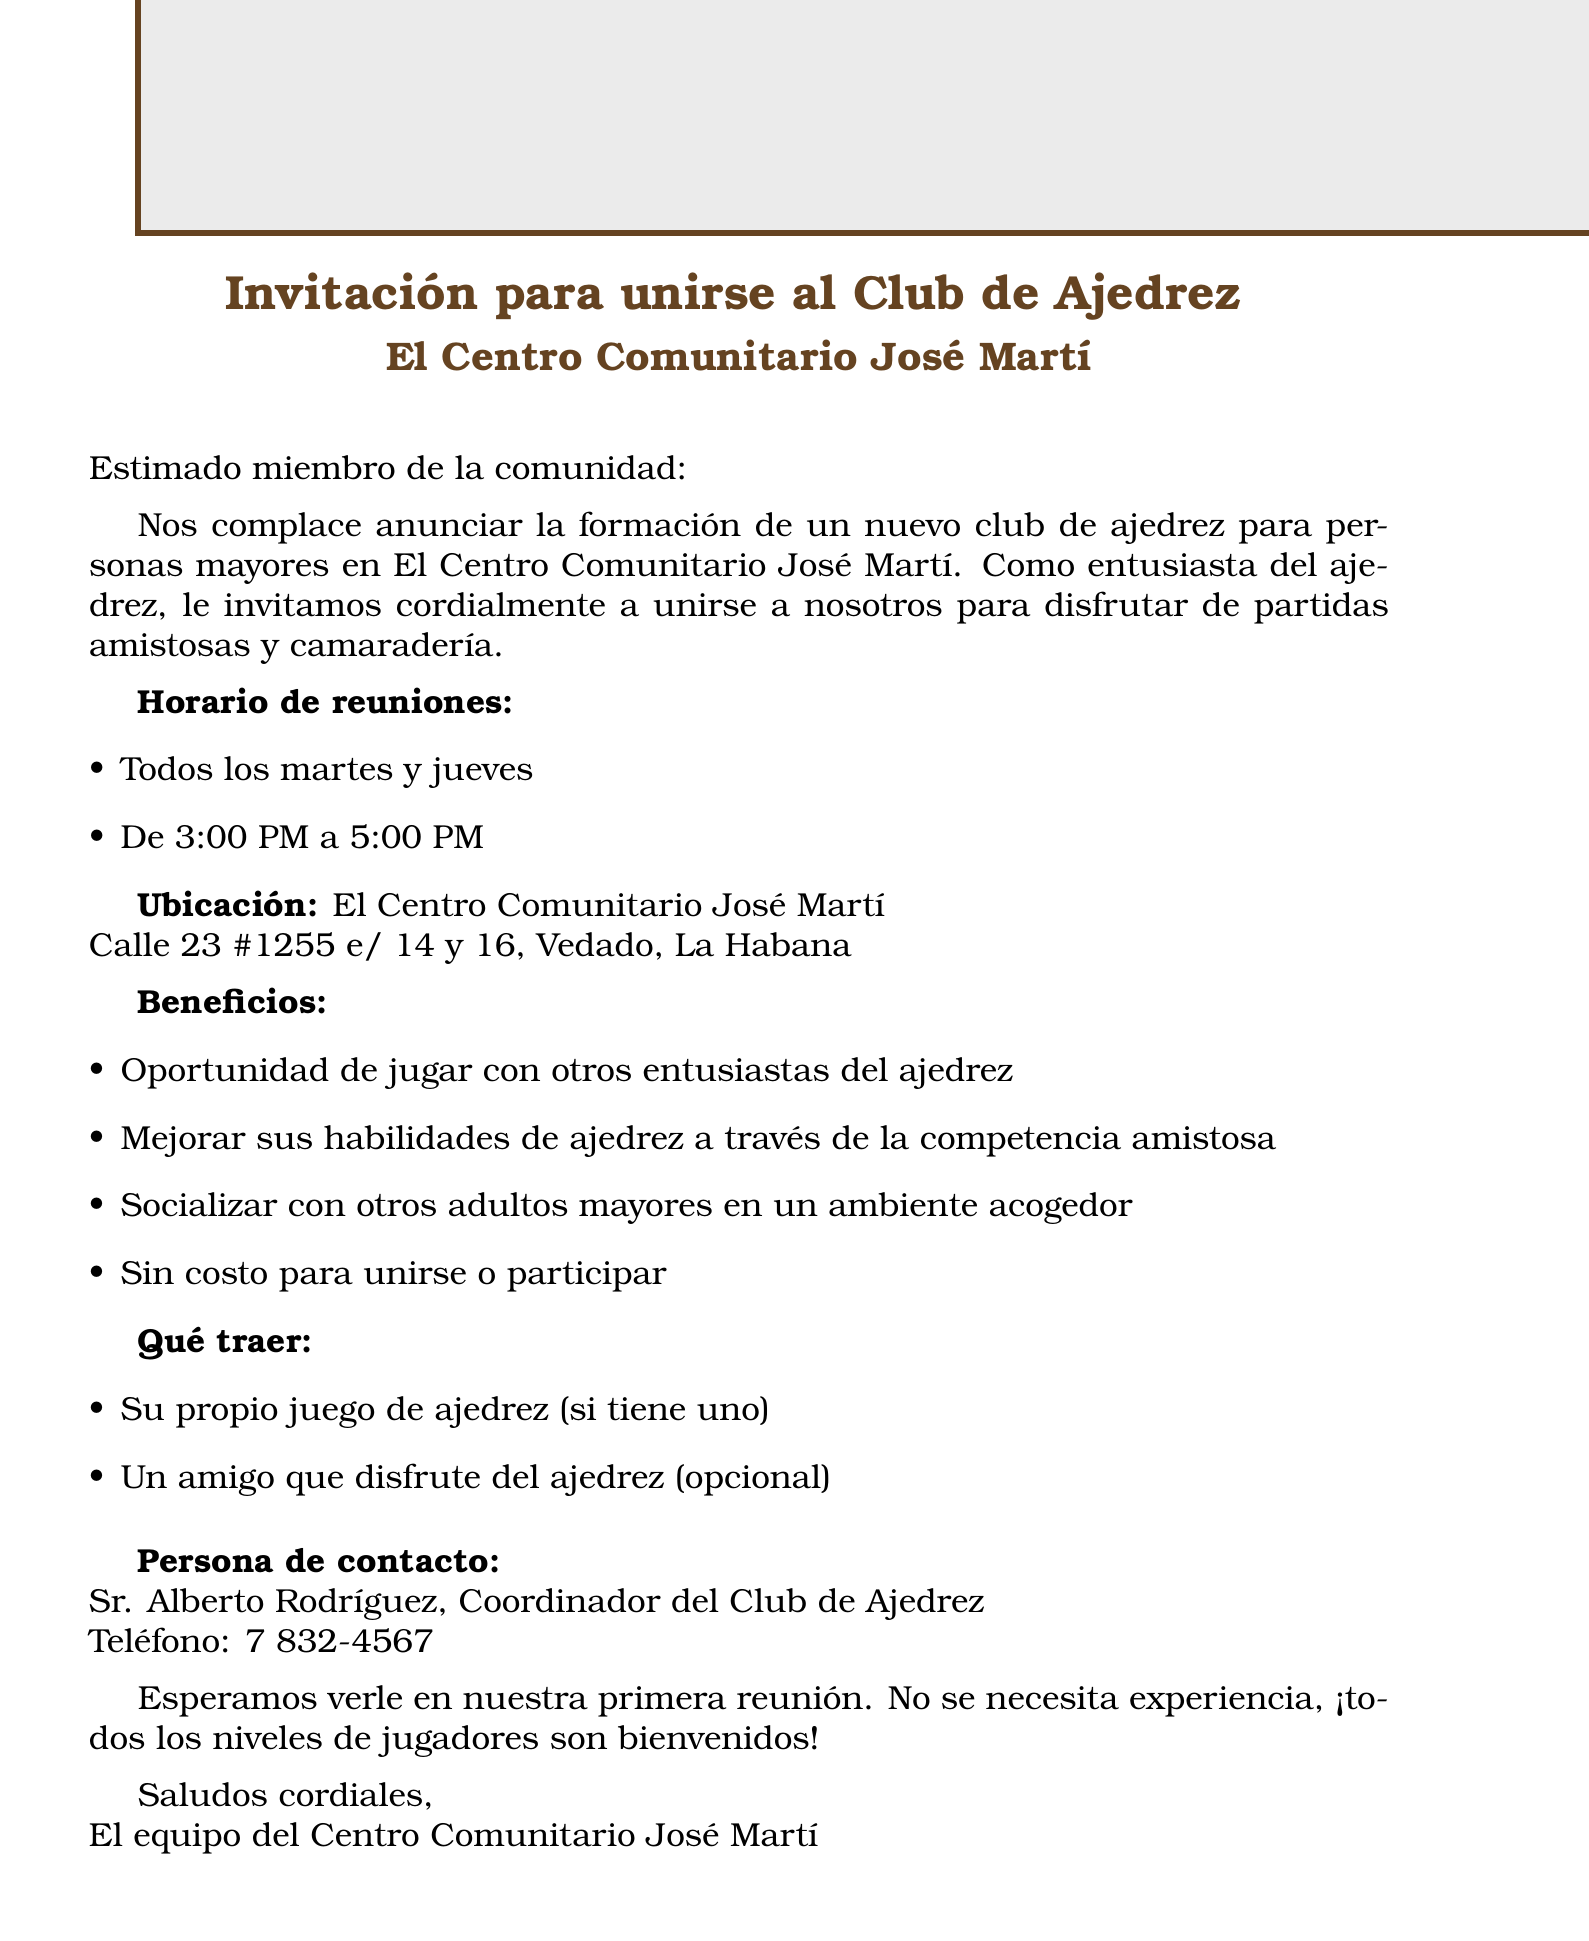what is the name of the chess club? The name of the chess club is mentioned in the invitation header as "El Centro Comunitario José Martí Chess Club for Seniors."
Answer: El Centro Comunitario José Martí Chess Club for Seniors what days are the meetings held? The document specifies that meetings are held every Tuesday and Thursday.
Answer: Every Tuesday and Thursday what are the meeting times? The meeting times are provided in the document as "3:00 PM to 5:00 PM."
Answer: 3:00 PM to 5:00 PM where is the chess club located? The location of the chess club is mentioned in the document as "Calle 23 #1255 e/ 14 y 16, Vedado, La Habana."
Answer: Calle 23 #1255 e/ 14 y 16, Vedado, La Habana who is the contact person for the chess club? The document includes the contact person's name and title, identifying them as "Sr. Alberto Rodríguez, Chess Club Coordinator."
Answer: Sr. Alberto Rodríguez how much does it cost to join the chess club? The document states that there is no cost to join or participate in the chess club.
Answer: No cost what should participants bring? The document mentions that participants should bring their own chess set if they have one, and optionally, a friend.
Answer: Your own chess set (if you have one) what is the purpose of the chess club? The document highlights one of the main purposes which is to provide opportunities for friendly matches and socialization among seniors.
Answer: Friendly matches and camaraderie what level of chess experience is required to join? The closing statement of the document indicates that no experience is necessary to participate in the chess club.
Answer: No experience necessary 